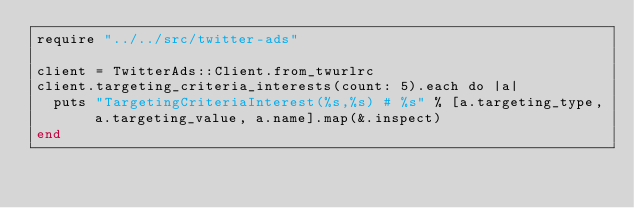<code> <loc_0><loc_0><loc_500><loc_500><_Crystal_>require "../../src/twitter-ads"

client = TwitterAds::Client.from_twurlrc
client.targeting_criteria_interests(count: 5).each do |a|
  puts "TargetingCriteriaInterest(%s,%s) # %s" % [a.targeting_type, a.targeting_value, a.name].map(&.inspect)
end
</code> 